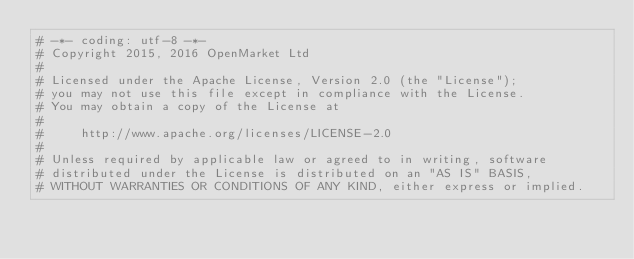<code> <loc_0><loc_0><loc_500><loc_500><_Python_># -*- coding: utf-8 -*-
# Copyright 2015, 2016 OpenMarket Ltd
#
# Licensed under the Apache License, Version 2.0 (the "License");
# you may not use this file except in compliance with the License.
# You may obtain a copy of the License at
#
#     http://www.apache.org/licenses/LICENSE-2.0
#
# Unless required by applicable law or agreed to in writing, software
# distributed under the License is distributed on an "AS IS" BASIS,
# WITHOUT WARRANTIES OR CONDITIONS OF ANY KIND, either express or implied.</code> 